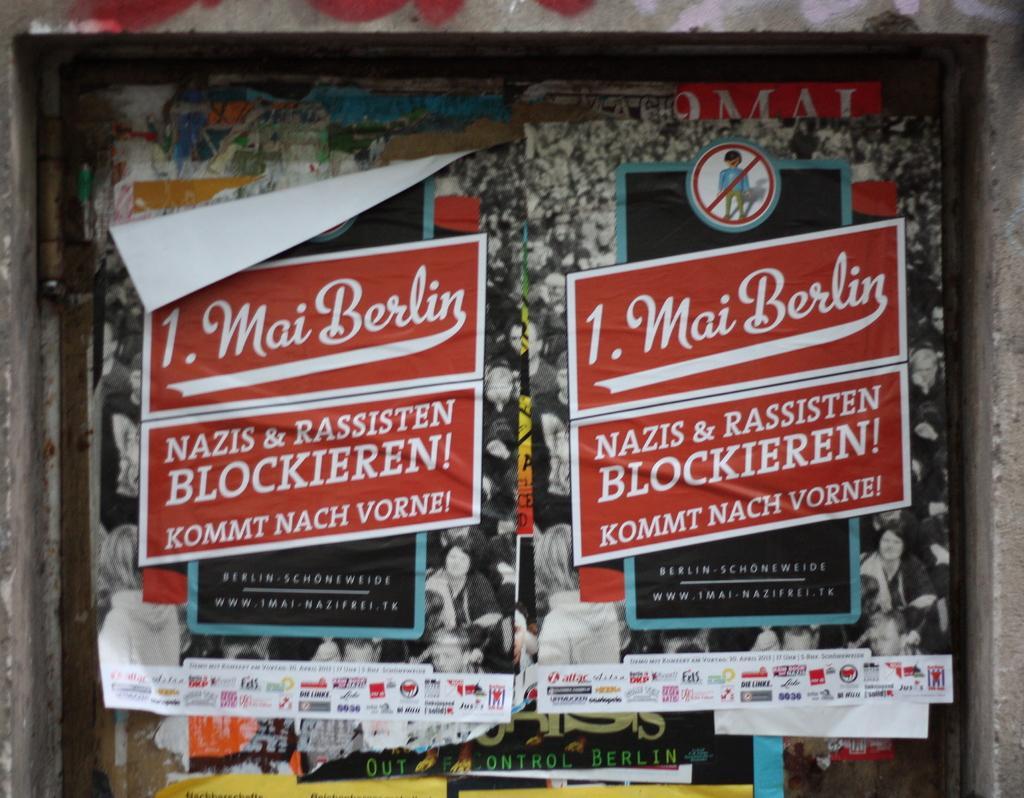How would you summarize this image in a sentence or two? In this image I can see few papers attached to the wall, the papers are in red and white color. Background I can see a black color paper. 